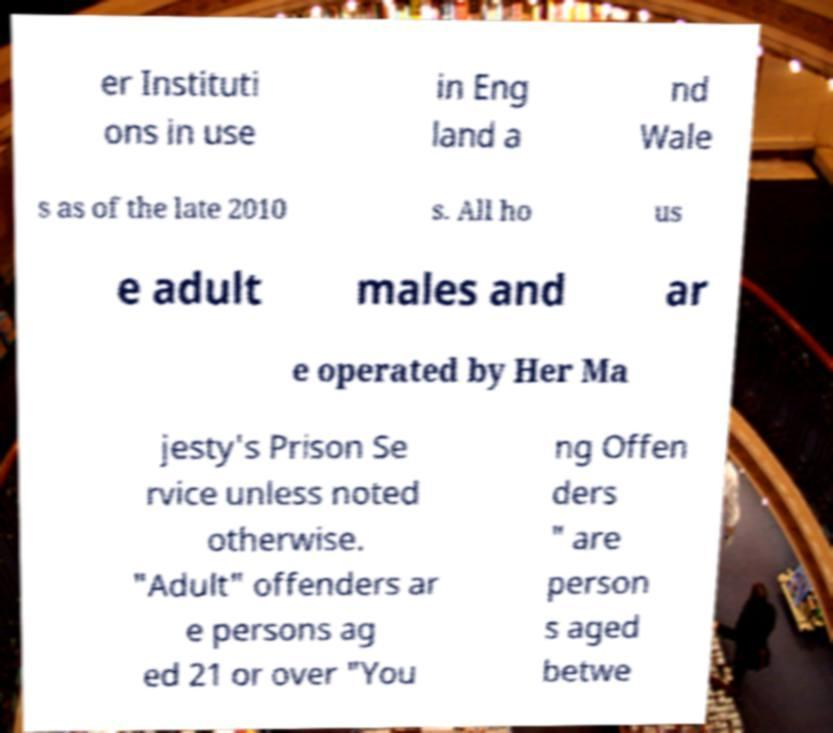Please identify and transcribe the text found in this image. er Instituti ons in use in Eng land a nd Wale s as of the late 2010 s. All ho us e adult males and ar e operated by Her Ma jesty's Prison Se rvice unless noted otherwise. "Adult" offenders ar e persons ag ed 21 or over "You ng Offen ders " are person s aged betwe 